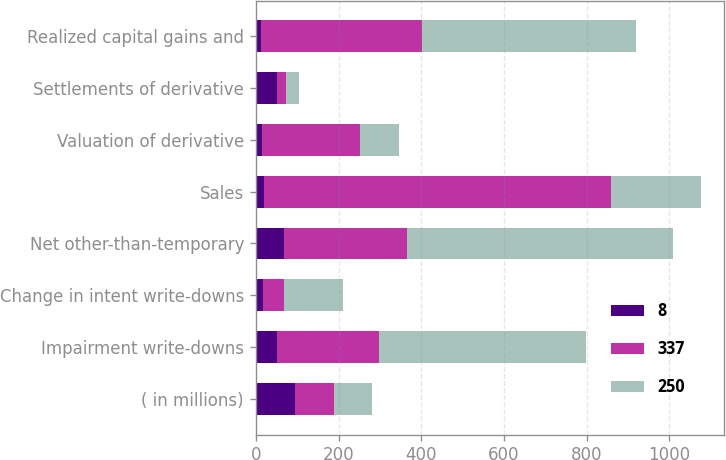Convert chart to OTSL. <chart><loc_0><loc_0><loc_500><loc_500><stacked_bar_chart><ecel><fcel>( in millions)<fcel>Impairment write-downs<fcel>Change in intent write-downs<fcel>Net other-than-temporary<fcel>Sales<fcel>Valuation of derivative<fcel>Settlements of derivative<fcel>Realized capital gains and<nl><fcel>8<fcel>94<fcel>51<fcel>17<fcel>68<fcel>20<fcel>16<fcel>51<fcel>13<nl><fcel>337<fcel>94<fcel>246<fcel>51<fcel>297<fcel>838<fcel>237<fcel>22<fcel>388<nl><fcel>250<fcel>94<fcel>501<fcel>142<fcel>643<fcel>219<fcel>94<fcel>31<fcel>517<nl></chart> 